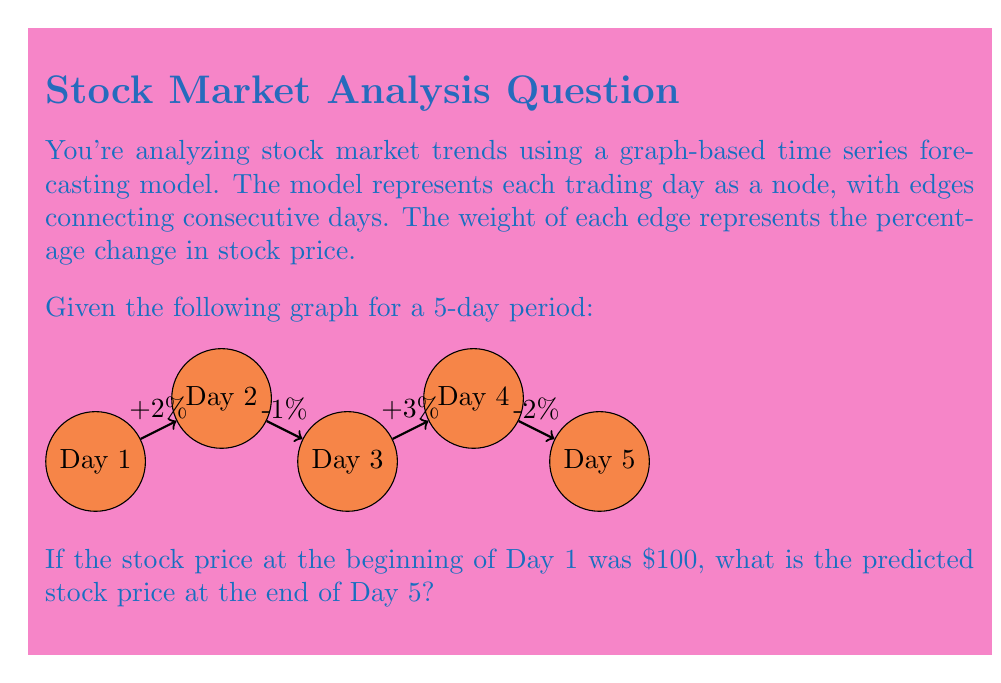Solve this math problem. Let's approach this step-by-step:

1) We start with a stock price of $100 on Day 1.

2) For each day, we need to calculate the new price based on the percentage change:

   Day 1 to Day 2: +2%
   $100 * (1 + 0.02) = $102$

   Day 2 to Day 3: -1%
   $102 * (1 - 0.01) = $100.98$

   Day 3 to Day 4: +3%
   $100.98 * (1 + 0.03) = $104.0094$

   Day 4 to Day 5: -2%
   $104.0094 * (1 - 0.02) = $101.929212$

3) We can also calculate this in one step using the compound effect of all changes:

   $100 * (1 + 0.02) * (1 - 0.01) * (1 + 0.03) * (1 - 0.02) = 101.929212$

4) Rounding to the nearest cent (as is common in finance):

   $101.93

Thus, the predicted stock price at the end of Day 5 is $101.93.
Answer: $101.93 